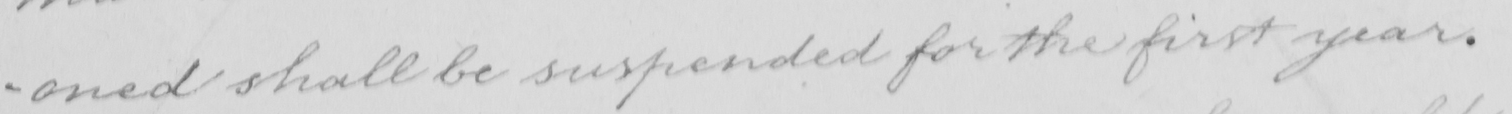Can you tell me what this handwritten text says? -oned shall be suspended for the first year . 